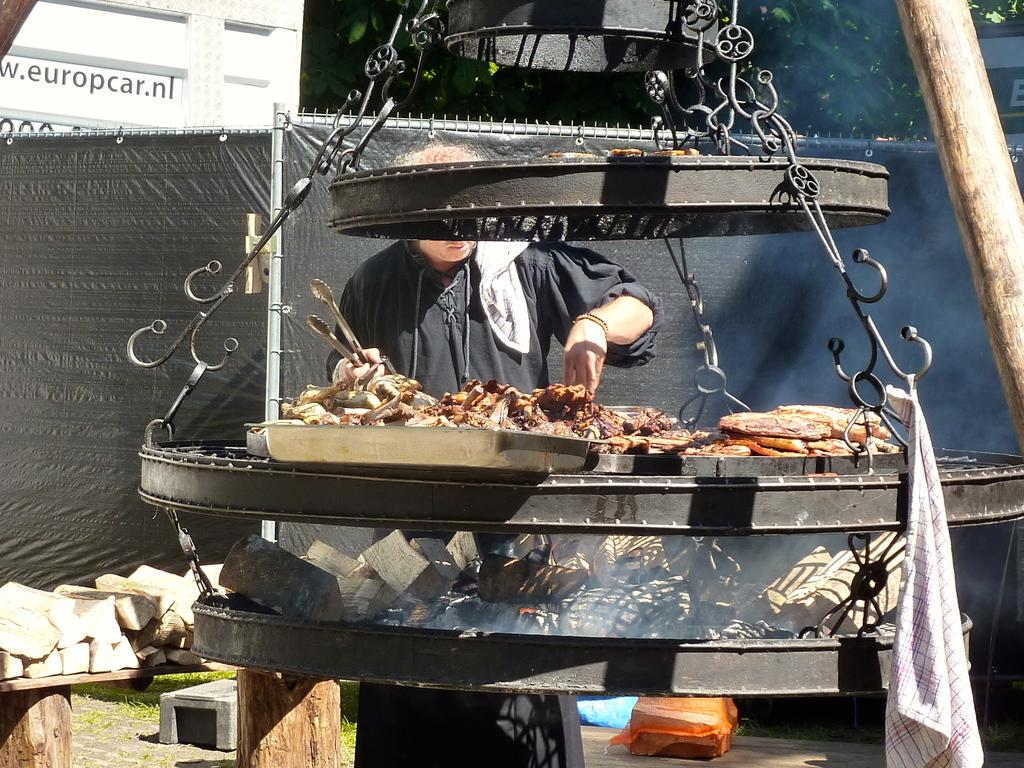Provide a one-sentence caption for the provided image. A man prepares meats in front of a building advertising europcar.nl. 